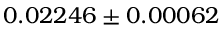<formula> <loc_0><loc_0><loc_500><loc_500>0 . 0 2 2 4 6 \pm 0 . 0 0 0 6 2</formula> 